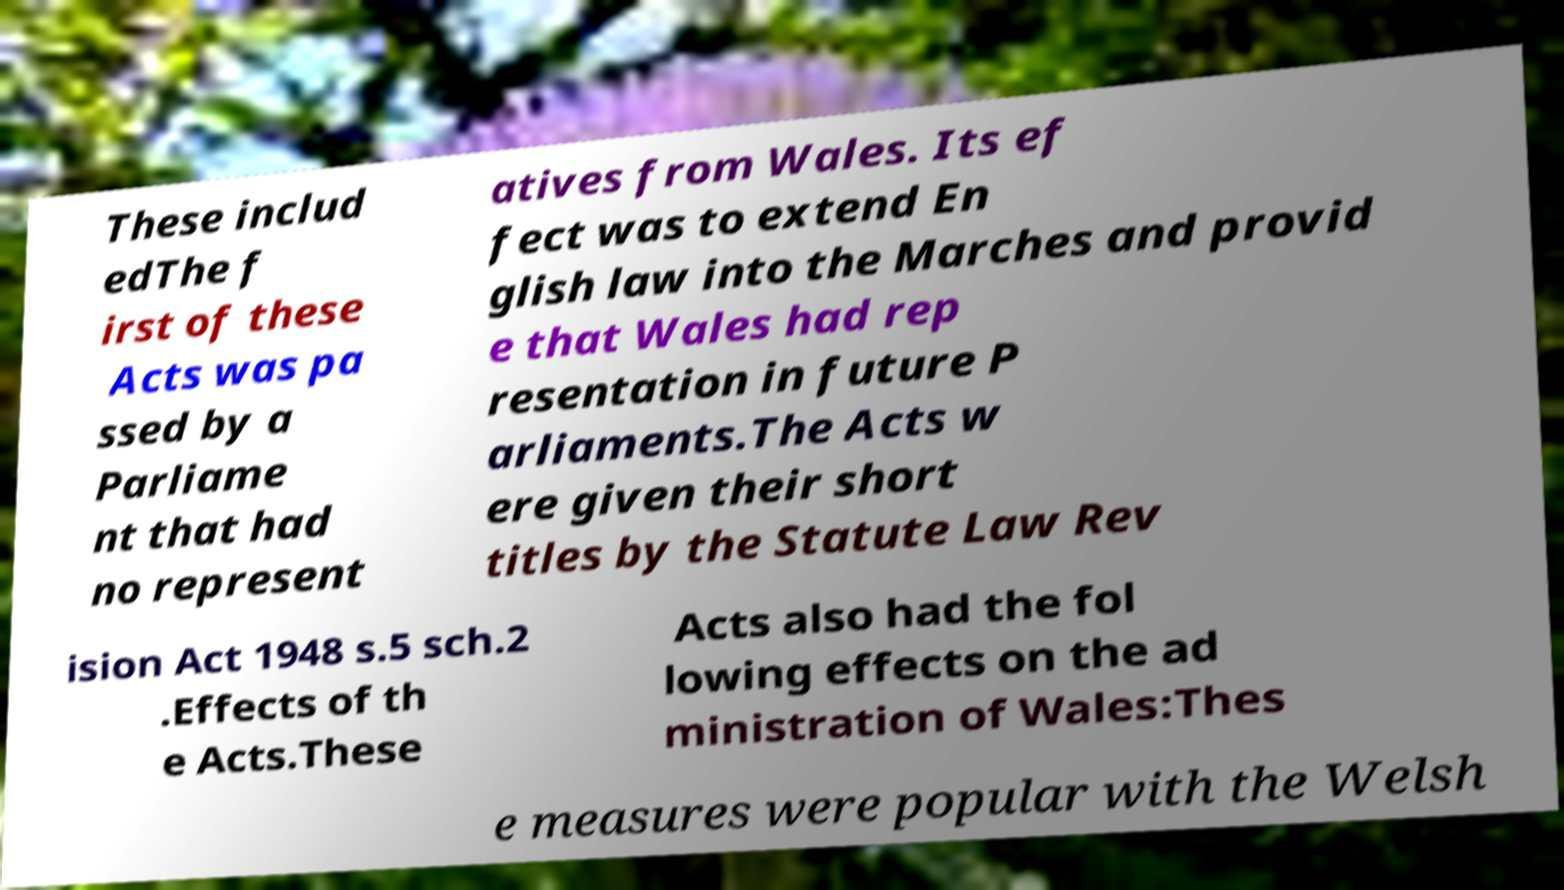What messages or text are displayed in this image? I need them in a readable, typed format. These includ edThe f irst of these Acts was pa ssed by a Parliame nt that had no represent atives from Wales. Its ef fect was to extend En glish law into the Marches and provid e that Wales had rep resentation in future P arliaments.The Acts w ere given their short titles by the Statute Law Rev ision Act 1948 s.5 sch.2 .Effects of th e Acts.These Acts also had the fol lowing effects on the ad ministration of Wales:Thes e measures were popular with the Welsh 